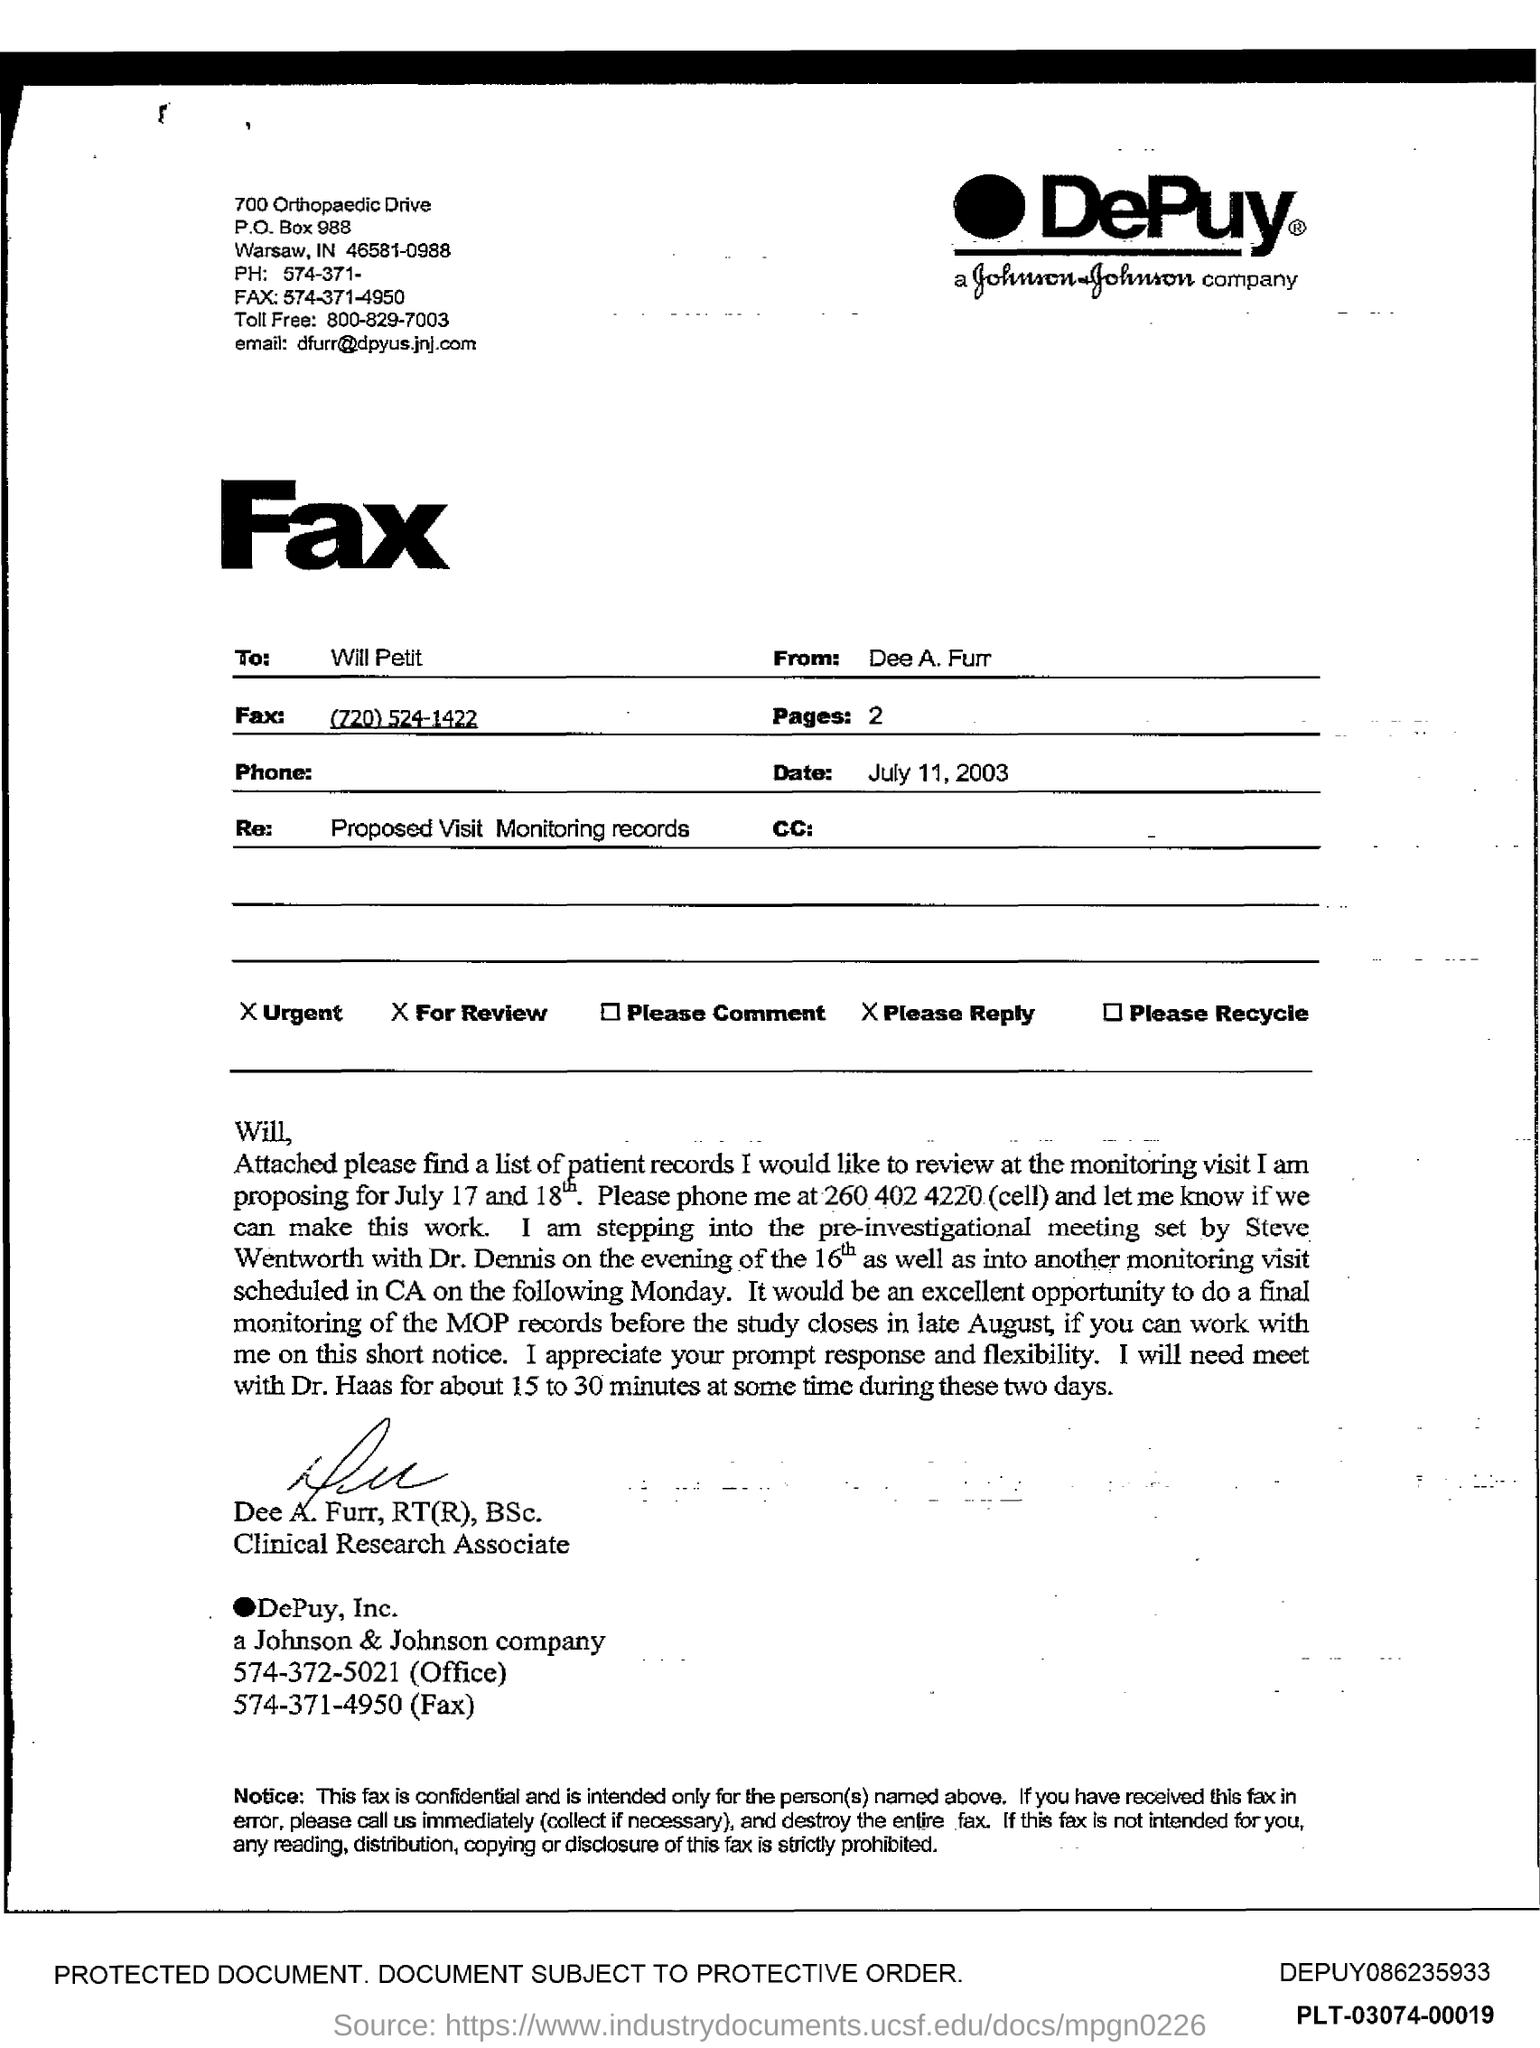What is the PO Box Number mentioned in the document?
Your response must be concise. 988. What is the toll free number?
Give a very brief answer. 800-829-7003. What is the Email id?
Offer a terse response. Dfurr@dpyus.jnj.com. 